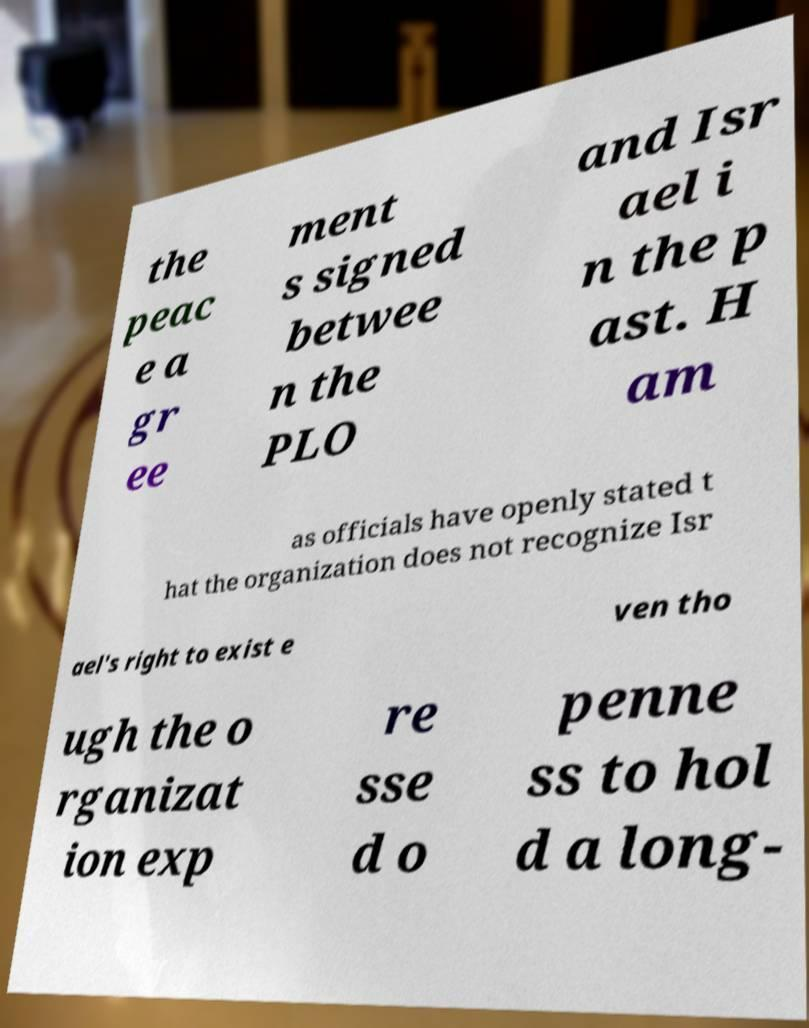There's text embedded in this image that I need extracted. Can you transcribe it verbatim? the peac e a gr ee ment s signed betwee n the PLO and Isr ael i n the p ast. H am as officials have openly stated t hat the organization does not recognize Isr ael's right to exist e ven tho ugh the o rganizat ion exp re sse d o penne ss to hol d a long- 